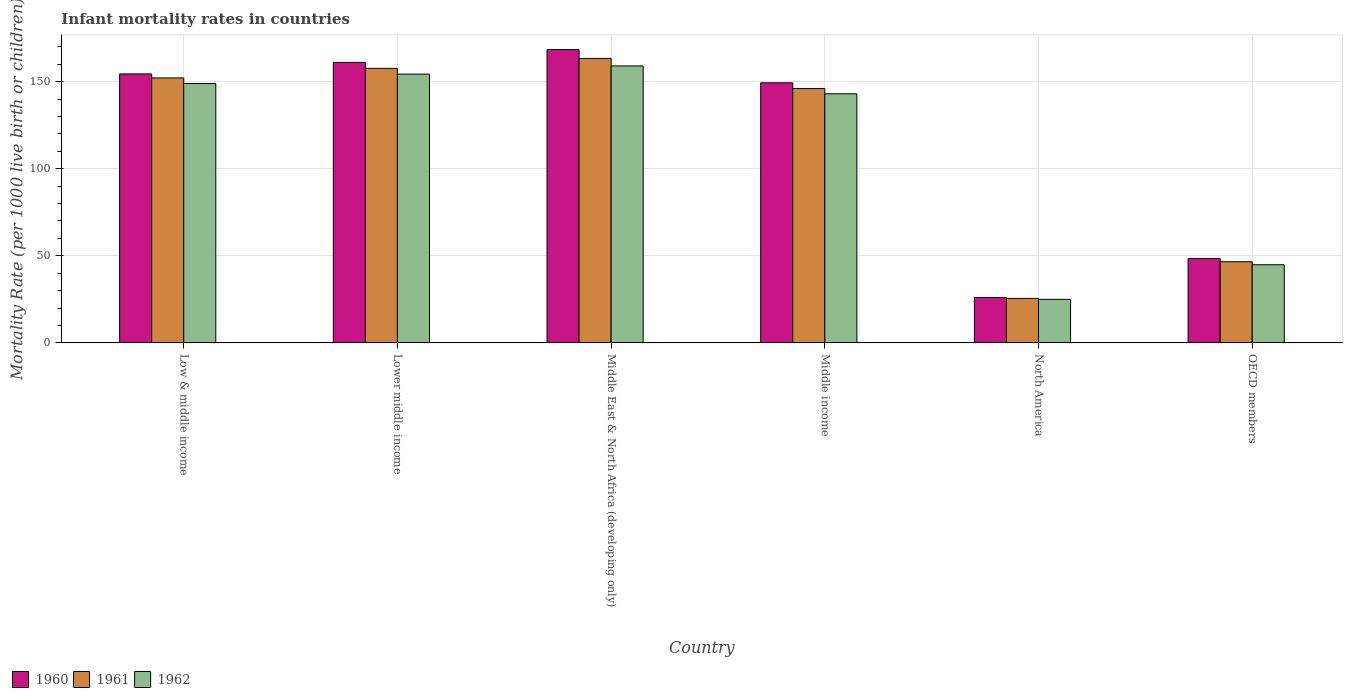How many groups of bars are there?
Your answer should be compact. 6. Are the number of bars per tick equal to the number of legend labels?
Make the answer very short. Yes. Are the number of bars on each tick of the X-axis equal?
Provide a short and direct response. Yes. How many bars are there on the 3rd tick from the left?
Offer a very short reply. 3. How many bars are there on the 1st tick from the right?
Your answer should be very brief. 3. What is the label of the 4th group of bars from the left?
Make the answer very short. Middle income. What is the infant mortality rate in 1962 in Low & middle income?
Your response must be concise. 148.9. Across all countries, what is the maximum infant mortality rate in 1960?
Keep it short and to the point. 168.4. Across all countries, what is the minimum infant mortality rate in 1962?
Your answer should be compact. 25.01. In which country was the infant mortality rate in 1960 maximum?
Offer a very short reply. Middle East & North Africa (developing only). In which country was the infant mortality rate in 1961 minimum?
Offer a terse response. North America. What is the total infant mortality rate in 1961 in the graph?
Offer a very short reply. 691.17. What is the difference between the infant mortality rate in 1962 in Low & middle income and that in OECD members?
Provide a short and direct response. 104.03. What is the difference between the infant mortality rate in 1961 in OECD members and the infant mortality rate in 1960 in North America?
Your answer should be very brief. 20.53. What is the average infant mortality rate in 1960 per country?
Provide a short and direct response. 117.95. What is the difference between the infant mortality rate of/in 1961 and infant mortality rate of/in 1962 in OECD members?
Keep it short and to the point. 1.74. In how many countries, is the infant mortality rate in 1960 greater than 10?
Give a very brief answer. 6. What is the ratio of the infant mortality rate in 1961 in Lower middle income to that in Middle income?
Give a very brief answer. 1.08. Is the infant mortality rate in 1960 in Lower middle income less than that in OECD members?
Your response must be concise. No. Is the difference between the infant mortality rate in 1961 in Middle East & North Africa (developing only) and North America greater than the difference between the infant mortality rate in 1962 in Middle East & North Africa (developing only) and North America?
Ensure brevity in your answer.  Yes. What is the difference between the highest and the second highest infant mortality rate in 1961?
Your response must be concise. -11.2. What is the difference between the highest and the lowest infant mortality rate in 1962?
Keep it short and to the point. 133.99. What does the 2nd bar from the right in Middle income represents?
Make the answer very short. 1961. What is the difference between two consecutive major ticks on the Y-axis?
Ensure brevity in your answer.  50. Are the values on the major ticks of Y-axis written in scientific E-notation?
Provide a succinct answer. No. Does the graph contain any zero values?
Provide a succinct answer. No. Does the graph contain grids?
Offer a terse response. Yes. How many legend labels are there?
Your answer should be compact. 3. What is the title of the graph?
Keep it short and to the point. Infant mortality rates in countries. What is the label or title of the X-axis?
Your response must be concise. Country. What is the label or title of the Y-axis?
Offer a very short reply. Mortality Rate (per 1000 live birth or children). What is the Mortality Rate (per 1000 live birth or children) in 1960 in Low & middle income?
Offer a terse response. 154.4. What is the Mortality Rate (per 1000 live birth or children) in 1961 in Low & middle income?
Offer a terse response. 152.1. What is the Mortality Rate (per 1000 live birth or children) in 1962 in Low & middle income?
Provide a short and direct response. 148.9. What is the Mortality Rate (per 1000 live birth or children) in 1960 in Lower middle income?
Offer a terse response. 161. What is the Mortality Rate (per 1000 live birth or children) of 1961 in Lower middle income?
Your response must be concise. 157.6. What is the Mortality Rate (per 1000 live birth or children) of 1962 in Lower middle income?
Provide a succinct answer. 154.3. What is the Mortality Rate (per 1000 live birth or children) of 1960 in Middle East & North Africa (developing only)?
Provide a short and direct response. 168.4. What is the Mortality Rate (per 1000 live birth or children) of 1961 in Middle East & North Africa (developing only)?
Provide a succinct answer. 163.3. What is the Mortality Rate (per 1000 live birth or children) of 1962 in Middle East & North Africa (developing only)?
Offer a terse response. 159. What is the Mortality Rate (per 1000 live birth or children) in 1960 in Middle income?
Provide a succinct answer. 149.3. What is the Mortality Rate (per 1000 live birth or children) in 1961 in Middle income?
Give a very brief answer. 146. What is the Mortality Rate (per 1000 live birth or children) in 1962 in Middle income?
Keep it short and to the point. 143. What is the Mortality Rate (per 1000 live birth or children) of 1960 in North America?
Provide a short and direct response. 26.08. What is the Mortality Rate (per 1000 live birth or children) of 1961 in North America?
Offer a very short reply. 25.56. What is the Mortality Rate (per 1000 live birth or children) of 1962 in North America?
Ensure brevity in your answer.  25.01. What is the Mortality Rate (per 1000 live birth or children) in 1960 in OECD members?
Offer a very short reply. 48.51. What is the Mortality Rate (per 1000 live birth or children) of 1961 in OECD members?
Ensure brevity in your answer.  46.61. What is the Mortality Rate (per 1000 live birth or children) of 1962 in OECD members?
Make the answer very short. 44.87. Across all countries, what is the maximum Mortality Rate (per 1000 live birth or children) of 1960?
Keep it short and to the point. 168.4. Across all countries, what is the maximum Mortality Rate (per 1000 live birth or children) of 1961?
Provide a short and direct response. 163.3. Across all countries, what is the maximum Mortality Rate (per 1000 live birth or children) in 1962?
Offer a terse response. 159. Across all countries, what is the minimum Mortality Rate (per 1000 live birth or children) of 1960?
Offer a very short reply. 26.08. Across all countries, what is the minimum Mortality Rate (per 1000 live birth or children) in 1961?
Ensure brevity in your answer.  25.56. Across all countries, what is the minimum Mortality Rate (per 1000 live birth or children) in 1962?
Your response must be concise. 25.01. What is the total Mortality Rate (per 1000 live birth or children) of 1960 in the graph?
Make the answer very short. 707.69. What is the total Mortality Rate (per 1000 live birth or children) in 1961 in the graph?
Give a very brief answer. 691.17. What is the total Mortality Rate (per 1000 live birth or children) in 1962 in the graph?
Ensure brevity in your answer.  675.08. What is the difference between the Mortality Rate (per 1000 live birth or children) of 1960 in Low & middle income and that in Lower middle income?
Provide a short and direct response. -6.6. What is the difference between the Mortality Rate (per 1000 live birth or children) of 1961 in Low & middle income and that in Lower middle income?
Give a very brief answer. -5.5. What is the difference between the Mortality Rate (per 1000 live birth or children) of 1962 in Low & middle income and that in Middle East & North Africa (developing only)?
Your answer should be very brief. -10.1. What is the difference between the Mortality Rate (per 1000 live birth or children) in 1960 in Low & middle income and that in Middle income?
Give a very brief answer. 5.1. What is the difference between the Mortality Rate (per 1000 live birth or children) of 1962 in Low & middle income and that in Middle income?
Keep it short and to the point. 5.9. What is the difference between the Mortality Rate (per 1000 live birth or children) of 1960 in Low & middle income and that in North America?
Provide a succinct answer. 128.32. What is the difference between the Mortality Rate (per 1000 live birth or children) of 1961 in Low & middle income and that in North America?
Offer a very short reply. 126.54. What is the difference between the Mortality Rate (per 1000 live birth or children) of 1962 in Low & middle income and that in North America?
Ensure brevity in your answer.  123.89. What is the difference between the Mortality Rate (per 1000 live birth or children) of 1960 in Low & middle income and that in OECD members?
Offer a terse response. 105.89. What is the difference between the Mortality Rate (per 1000 live birth or children) in 1961 in Low & middle income and that in OECD members?
Ensure brevity in your answer.  105.49. What is the difference between the Mortality Rate (per 1000 live birth or children) in 1962 in Low & middle income and that in OECD members?
Your answer should be compact. 104.03. What is the difference between the Mortality Rate (per 1000 live birth or children) in 1962 in Lower middle income and that in Middle East & North Africa (developing only)?
Make the answer very short. -4.7. What is the difference between the Mortality Rate (per 1000 live birth or children) of 1960 in Lower middle income and that in Middle income?
Ensure brevity in your answer.  11.7. What is the difference between the Mortality Rate (per 1000 live birth or children) in 1960 in Lower middle income and that in North America?
Offer a terse response. 134.92. What is the difference between the Mortality Rate (per 1000 live birth or children) of 1961 in Lower middle income and that in North America?
Make the answer very short. 132.04. What is the difference between the Mortality Rate (per 1000 live birth or children) in 1962 in Lower middle income and that in North America?
Keep it short and to the point. 129.29. What is the difference between the Mortality Rate (per 1000 live birth or children) in 1960 in Lower middle income and that in OECD members?
Your answer should be compact. 112.49. What is the difference between the Mortality Rate (per 1000 live birth or children) in 1961 in Lower middle income and that in OECD members?
Offer a terse response. 110.99. What is the difference between the Mortality Rate (per 1000 live birth or children) of 1962 in Lower middle income and that in OECD members?
Make the answer very short. 109.43. What is the difference between the Mortality Rate (per 1000 live birth or children) in 1962 in Middle East & North Africa (developing only) and that in Middle income?
Ensure brevity in your answer.  16. What is the difference between the Mortality Rate (per 1000 live birth or children) in 1960 in Middle East & North Africa (developing only) and that in North America?
Give a very brief answer. 142.32. What is the difference between the Mortality Rate (per 1000 live birth or children) of 1961 in Middle East & North Africa (developing only) and that in North America?
Give a very brief answer. 137.74. What is the difference between the Mortality Rate (per 1000 live birth or children) in 1962 in Middle East & North Africa (developing only) and that in North America?
Provide a short and direct response. 133.99. What is the difference between the Mortality Rate (per 1000 live birth or children) of 1960 in Middle East & North Africa (developing only) and that in OECD members?
Provide a succinct answer. 119.89. What is the difference between the Mortality Rate (per 1000 live birth or children) in 1961 in Middle East & North Africa (developing only) and that in OECD members?
Provide a short and direct response. 116.69. What is the difference between the Mortality Rate (per 1000 live birth or children) in 1962 in Middle East & North Africa (developing only) and that in OECD members?
Provide a short and direct response. 114.13. What is the difference between the Mortality Rate (per 1000 live birth or children) of 1960 in Middle income and that in North America?
Your answer should be compact. 123.22. What is the difference between the Mortality Rate (per 1000 live birth or children) of 1961 in Middle income and that in North America?
Ensure brevity in your answer.  120.44. What is the difference between the Mortality Rate (per 1000 live birth or children) of 1962 in Middle income and that in North America?
Make the answer very short. 117.99. What is the difference between the Mortality Rate (per 1000 live birth or children) in 1960 in Middle income and that in OECD members?
Ensure brevity in your answer.  100.79. What is the difference between the Mortality Rate (per 1000 live birth or children) in 1961 in Middle income and that in OECD members?
Offer a very short reply. 99.39. What is the difference between the Mortality Rate (per 1000 live birth or children) of 1962 in Middle income and that in OECD members?
Your answer should be compact. 98.13. What is the difference between the Mortality Rate (per 1000 live birth or children) of 1960 in North America and that in OECD members?
Your response must be concise. -22.42. What is the difference between the Mortality Rate (per 1000 live birth or children) of 1961 in North America and that in OECD members?
Your response must be concise. -21.06. What is the difference between the Mortality Rate (per 1000 live birth or children) of 1962 in North America and that in OECD members?
Provide a succinct answer. -19.86. What is the difference between the Mortality Rate (per 1000 live birth or children) of 1960 in Low & middle income and the Mortality Rate (per 1000 live birth or children) of 1962 in Lower middle income?
Offer a terse response. 0.1. What is the difference between the Mortality Rate (per 1000 live birth or children) of 1961 in Low & middle income and the Mortality Rate (per 1000 live birth or children) of 1962 in Lower middle income?
Your answer should be compact. -2.2. What is the difference between the Mortality Rate (per 1000 live birth or children) in 1960 in Low & middle income and the Mortality Rate (per 1000 live birth or children) in 1961 in Middle East & North Africa (developing only)?
Offer a terse response. -8.9. What is the difference between the Mortality Rate (per 1000 live birth or children) in 1960 in Low & middle income and the Mortality Rate (per 1000 live birth or children) in 1962 in Middle East & North Africa (developing only)?
Provide a succinct answer. -4.6. What is the difference between the Mortality Rate (per 1000 live birth or children) in 1961 in Low & middle income and the Mortality Rate (per 1000 live birth or children) in 1962 in Middle East & North Africa (developing only)?
Offer a terse response. -6.9. What is the difference between the Mortality Rate (per 1000 live birth or children) in 1960 in Low & middle income and the Mortality Rate (per 1000 live birth or children) in 1961 in Middle income?
Give a very brief answer. 8.4. What is the difference between the Mortality Rate (per 1000 live birth or children) in 1960 in Low & middle income and the Mortality Rate (per 1000 live birth or children) in 1961 in North America?
Your answer should be compact. 128.84. What is the difference between the Mortality Rate (per 1000 live birth or children) in 1960 in Low & middle income and the Mortality Rate (per 1000 live birth or children) in 1962 in North America?
Provide a short and direct response. 129.39. What is the difference between the Mortality Rate (per 1000 live birth or children) of 1961 in Low & middle income and the Mortality Rate (per 1000 live birth or children) of 1962 in North America?
Keep it short and to the point. 127.09. What is the difference between the Mortality Rate (per 1000 live birth or children) of 1960 in Low & middle income and the Mortality Rate (per 1000 live birth or children) of 1961 in OECD members?
Make the answer very short. 107.79. What is the difference between the Mortality Rate (per 1000 live birth or children) of 1960 in Low & middle income and the Mortality Rate (per 1000 live birth or children) of 1962 in OECD members?
Provide a short and direct response. 109.53. What is the difference between the Mortality Rate (per 1000 live birth or children) in 1961 in Low & middle income and the Mortality Rate (per 1000 live birth or children) in 1962 in OECD members?
Your response must be concise. 107.23. What is the difference between the Mortality Rate (per 1000 live birth or children) in 1960 in Lower middle income and the Mortality Rate (per 1000 live birth or children) in 1962 in Middle East & North Africa (developing only)?
Provide a short and direct response. 2. What is the difference between the Mortality Rate (per 1000 live birth or children) in 1960 in Lower middle income and the Mortality Rate (per 1000 live birth or children) in 1961 in Middle income?
Offer a terse response. 15. What is the difference between the Mortality Rate (per 1000 live birth or children) of 1960 in Lower middle income and the Mortality Rate (per 1000 live birth or children) of 1962 in Middle income?
Offer a terse response. 18. What is the difference between the Mortality Rate (per 1000 live birth or children) of 1960 in Lower middle income and the Mortality Rate (per 1000 live birth or children) of 1961 in North America?
Your response must be concise. 135.44. What is the difference between the Mortality Rate (per 1000 live birth or children) of 1960 in Lower middle income and the Mortality Rate (per 1000 live birth or children) of 1962 in North America?
Offer a very short reply. 135.99. What is the difference between the Mortality Rate (per 1000 live birth or children) in 1961 in Lower middle income and the Mortality Rate (per 1000 live birth or children) in 1962 in North America?
Your answer should be compact. 132.59. What is the difference between the Mortality Rate (per 1000 live birth or children) in 1960 in Lower middle income and the Mortality Rate (per 1000 live birth or children) in 1961 in OECD members?
Your answer should be very brief. 114.39. What is the difference between the Mortality Rate (per 1000 live birth or children) of 1960 in Lower middle income and the Mortality Rate (per 1000 live birth or children) of 1962 in OECD members?
Your answer should be compact. 116.13. What is the difference between the Mortality Rate (per 1000 live birth or children) of 1961 in Lower middle income and the Mortality Rate (per 1000 live birth or children) of 1962 in OECD members?
Provide a short and direct response. 112.73. What is the difference between the Mortality Rate (per 1000 live birth or children) in 1960 in Middle East & North Africa (developing only) and the Mortality Rate (per 1000 live birth or children) in 1961 in Middle income?
Make the answer very short. 22.4. What is the difference between the Mortality Rate (per 1000 live birth or children) of 1960 in Middle East & North Africa (developing only) and the Mortality Rate (per 1000 live birth or children) of 1962 in Middle income?
Provide a succinct answer. 25.4. What is the difference between the Mortality Rate (per 1000 live birth or children) of 1961 in Middle East & North Africa (developing only) and the Mortality Rate (per 1000 live birth or children) of 1962 in Middle income?
Provide a short and direct response. 20.3. What is the difference between the Mortality Rate (per 1000 live birth or children) in 1960 in Middle East & North Africa (developing only) and the Mortality Rate (per 1000 live birth or children) in 1961 in North America?
Keep it short and to the point. 142.84. What is the difference between the Mortality Rate (per 1000 live birth or children) in 1960 in Middle East & North Africa (developing only) and the Mortality Rate (per 1000 live birth or children) in 1962 in North America?
Make the answer very short. 143.39. What is the difference between the Mortality Rate (per 1000 live birth or children) of 1961 in Middle East & North Africa (developing only) and the Mortality Rate (per 1000 live birth or children) of 1962 in North America?
Ensure brevity in your answer.  138.29. What is the difference between the Mortality Rate (per 1000 live birth or children) in 1960 in Middle East & North Africa (developing only) and the Mortality Rate (per 1000 live birth or children) in 1961 in OECD members?
Your answer should be very brief. 121.79. What is the difference between the Mortality Rate (per 1000 live birth or children) in 1960 in Middle East & North Africa (developing only) and the Mortality Rate (per 1000 live birth or children) in 1962 in OECD members?
Keep it short and to the point. 123.53. What is the difference between the Mortality Rate (per 1000 live birth or children) of 1961 in Middle East & North Africa (developing only) and the Mortality Rate (per 1000 live birth or children) of 1962 in OECD members?
Your answer should be compact. 118.43. What is the difference between the Mortality Rate (per 1000 live birth or children) of 1960 in Middle income and the Mortality Rate (per 1000 live birth or children) of 1961 in North America?
Provide a succinct answer. 123.74. What is the difference between the Mortality Rate (per 1000 live birth or children) of 1960 in Middle income and the Mortality Rate (per 1000 live birth or children) of 1962 in North America?
Give a very brief answer. 124.29. What is the difference between the Mortality Rate (per 1000 live birth or children) in 1961 in Middle income and the Mortality Rate (per 1000 live birth or children) in 1962 in North America?
Provide a short and direct response. 120.99. What is the difference between the Mortality Rate (per 1000 live birth or children) in 1960 in Middle income and the Mortality Rate (per 1000 live birth or children) in 1961 in OECD members?
Provide a succinct answer. 102.69. What is the difference between the Mortality Rate (per 1000 live birth or children) of 1960 in Middle income and the Mortality Rate (per 1000 live birth or children) of 1962 in OECD members?
Provide a short and direct response. 104.43. What is the difference between the Mortality Rate (per 1000 live birth or children) of 1961 in Middle income and the Mortality Rate (per 1000 live birth or children) of 1962 in OECD members?
Your response must be concise. 101.13. What is the difference between the Mortality Rate (per 1000 live birth or children) in 1960 in North America and the Mortality Rate (per 1000 live birth or children) in 1961 in OECD members?
Your answer should be compact. -20.53. What is the difference between the Mortality Rate (per 1000 live birth or children) in 1960 in North America and the Mortality Rate (per 1000 live birth or children) in 1962 in OECD members?
Ensure brevity in your answer.  -18.79. What is the difference between the Mortality Rate (per 1000 live birth or children) of 1961 in North America and the Mortality Rate (per 1000 live birth or children) of 1962 in OECD members?
Your response must be concise. -19.32. What is the average Mortality Rate (per 1000 live birth or children) of 1960 per country?
Your answer should be compact. 117.95. What is the average Mortality Rate (per 1000 live birth or children) in 1961 per country?
Give a very brief answer. 115.19. What is the average Mortality Rate (per 1000 live birth or children) in 1962 per country?
Keep it short and to the point. 112.51. What is the difference between the Mortality Rate (per 1000 live birth or children) in 1960 and Mortality Rate (per 1000 live birth or children) in 1961 in Low & middle income?
Provide a short and direct response. 2.3. What is the difference between the Mortality Rate (per 1000 live birth or children) of 1960 and Mortality Rate (per 1000 live birth or children) of 1962 in Low & middle income?
Your answer should be compact. 5.5. What is the difference between the Mortality Rate (per 1000 live birth or children) of 1960 and Mortality Rate (per 1000 live birth or children) of 1961 in Lower middle income?
Give a very brief answer. 3.4. What is the difference between the Mortality Rate (per 1000 live birth or children) of 1961 and Mortality Rate (per 1000 live birth or children) of 1962 in Lower middle income?
Your answer should be very brief. 3.3. What is the difference between the Mortality Rate (per 1000 live birth or children) in 1960 and Mortality Rate (per 1000 live birth or children) in 1961 in North America?
Provide a succinct answer. 0.53. What is the difference between the Mortality Rate (per 1000 live birth or children) of 1960 and Mortality Rate (per 1000 live birth or children) of 1962 in North America?
Ensure brevity in your answer.  1.08. What is the difference between the Mortality Rate (per 1000 live birth or children) of 1961 and Mortality Rate (per 1000 live birth or children) of 1962 in North America?
Your response must be concise. 0.55. What is the difference between the Mortality Rate (per 1000 live birth or children) in 1960 and Mortality Rate (per 1000 live birth or children) in 1961 in OECD members?
Your response must be concise. 1.89. What is the difference between the Mortality Rate (per 1000 live birth or children) of 1960 and Mortality Rate (per 1000 live birth or children) of 1962 in OECD members?
Offer a terse response. 3.64. What is the difference between the Mortality Rate (per 1000 live birth or children) of 1961 and Mortality Rate (per 1000 live birth or children) of 1962 in OECD members?
Provide a succinct answer. 1.74. What is the ratio of the Mortality Rate (per 1000 live birth or children) in 1960 in Low & middle income to that in Lower middle income?
Give a very brief answer. 0.96. What is the ratio of the Mortality Rate (per 1000 live birth or children) in 1961 in Low & middle income to that in Lower middle income?
Your answer should be compact. 0.97. What is the ratio of the Mortality Rate (per 1000 live birth or children) of 1962 in Low & middle income to that in Lower middle income?
Give a very brief answer. 0.96. What is the ratio of the Mortality Rate (per 1000 live birth or children) of 1960 in Low & middle income to that in Middle East & North Africa (developing only)?
Keep it short and to the point. 0.92. What is the ratio of the Mortality Rate (per 1000 live birth or children) in 1961 in Low & middle income to that in Middle East & North Africa (developing only)?
Make the answer very short. 0.93. What is the ratio of the Mortality Rate (per 1000 live birth or children) in 1962 in Low & middle income to that in Middle East & North Africa (developing only)?
Ensure brevity in your answer.  0.94. What is the ratio of the Mortality Rate (per 1000 live birth or children) in 1960 in Low & middle income to that in Middle income?
Offer a very short reply. 1.03. What is the ratio of the Mortality Rate (per 1000 live birth or children) of 1961 in Low & middle income to that in Middle income?
Offer a terse response. 1.04. What is the ratio of the Mortality Rate (per 1000 live birth or children) of 1962 in Low & middle income to that in Middle income?
Provide a succinct answer. 1.04. What is the ratio of the Mortality Rate (per 1000 live birth or children) in 1960 in Low & middle income to that in North America?
Your answer should be very brief. 5.92. What is the ratio of the Mortality Rate (per 1000 live birth or children) of 1961 in Low & middle income to that in North America?
Provide a short and direct response. 5.95. What is the ratio of the Mortality Rate (per 1000 live birth or children) in 1962 in Low & middle income to that in North America?
Make the answer very short. 5.95. What is the ratio of the Mortality Rate (per 1000 live birth or children) in 1960 in Low & middle income to that in OECD members?
Offer a terse response. 3.18. What is the ratio of the Mortality Rate (per 1000 live birth or children) of 1961 in Low & middle income to that in OECD members?
Your response must be concise. 3.26. What is the ratio of the Mortality Rate (per 1000 live birth or children) of 1962 in Low & middle income to that in OECD members?
Give a very brief answer. 3.32. What is the ratio of the Mortality Rate (per 1000 live birth or children) in 1960 in Lower middle income to that in Middle East & North Africa (developing only)?
Offer a terse response. 0.96. What is the ratio of the Mortality Rate (per 1000 live birth or children) in 1961 in Lower middle income to that in Middle East & North Africa (developing only)?
Your answer should be compact. 0.97. What is the ratio of the Mortality Rate (per 1000 live birth or children) in 1962 in Lower middle income to that in Middle East & North Africa (developing only)?
Offer a terse response. 0.97. What is the ratio of the Mortality Rate (per 1000 live birth or children) of 1960 in Lower middle income to that in Middle income?
Ensure brevity in your answer.  1.08. What is the ratio of the Mortality Rate (per 1000 live birth or children) of 1961 in Lower middle income to that in Middle income?
Give a very brief answer. 1.08. What is the ratio of the Mortality Rate (per 1000 live birth or children) in 1962 in Lower middle income to that in Middle income?
Make the answer very short. 1.08. What is the ratio of the Mortality Rate (per 1000 live birth or children) of 1960 in Lower middle income to that in North America?
Provide a short and direct response. 6.17. What is the ratio of the Mortality Rate (per 1000 live birth or children) in 1961 in Lower middle income to that in North America?
Your answer should be compact. 6.17. What is the ratio of the Mortality Rate (per 1000 live birth or children) of 1962 in Lower middle income to that in North America?
Provide a short and direct response. 6.17. What is the ratio of the Mortality Rate (per 1000 live birth or children) of 1960 in Lower middle income to that in OECD members?
Give a very brief answer. 3.32. What is the ratio of the Mortality Rate (per 1000 live birth or children) of 1961 in Lower middle income to that in OECD members?
Your answer should be compact. 3.38. What is the ratio of the Mortality Rate (per 1000 live birth or children) in 1962 in Lower middle income to that in OECD members?
Offer a terse response. 3.44. What is the ratio of the Mortality Rate (per 1000 live birth or children) in 1960 in Middle East & North Africa (developing only) to that in Middle income?
Ensure brevity in your answer.  1.13. What is the ratio of the Mortality Rate (per 1000 live birth or children) in 1961 in Middle East & North Africa (developing only) to that in Middle income?
Provide a short and direct response. 1.12. What is the ratio of the Mortality Rate (per 1000 live birth or children) in 1962 in Middle East & North Africa (developing only) to that in Middle income?
Make the answer very short. 1.11. What is the ratio of the Mortality Rate (per 1000 live birth or children) in 1960 in Middle East & North Africa (developing only) to that in North America?
Your response must be concise. 6.46. What is the ratio of the Mortality Rate (per 1000 live birth or children) of 1961 in Middle East & North Africa (developing only) to that in North America?
Give a very brief answer. 6.39. What is the ratio of the Mortality Rate (per 1000 live birth or children) in 1962 in Middle East & North Africa (developing only) to that in North America?
Your response must be concise. 6.36. What is the ratio of the Mortality Rate (per 1000 live birth or children) of 1960 in Middle East & North Africa (developing only) to that in OECD members?
Your answer should be very brief. 3.47. What is the ratio of the Mortality Rate (per 1000 live birth or children) of 1961 in Middle East & North Africa (developing only) to that in OECD members?
Make the answer very short. 3.5. What is the ratio of the Mortality Rate (per 1000 live birth or children) in 1962 in Middle East & North Africa (developing only) to that in OECD members?
Make the answer very short. 3.54. What is the ratio of the Mortality Rate (per 1000 live birth or children) of 1960 in Middle income to that in North America?
Your answer should be compact. 5.72. What is the ratio of the Mortality Rate (per 1000 live birth or children) of 1961 in Middle income to that in North America?
Offer a terse response. 5.71. What is the ratio of the Mortality Rate (per 1000 live birth or children) of 1962 in Middle income to that in North America?
Offer a very short reply. 5.72. What is the ratio of the Mortality Rate (per 1000 live birth or children) in 1960 in Middle income to that in OECD members?
Ensure brevity in your answer.  3.08. What is the ratio of the Mortality Rate (per 1000 live birth or children) of 1961 in Middle income to that in OECD members?
Give a very brief answer. 3.13. What is the ratio of the Mortality Rate (per 1000 live birth or children) in 1962 in Middle income to that in OECD members?
Ensure brevity in your answer.  3.19. What is the ratio of the Mortality Rate (per 1000 live birth or children) in 1960 in North America to that in OECD members?
Offer a very short reply. 0.54. What is the ratio of the Mortality Rate (per 1000 live birth or children) of 1961 in North America to that in OECD members?
Your answer should be compact. 0.55. What is the ratio of the Mortality Rate (per 1000 live birth or children) in 1962 in North America to that in OECD members?
Provide a short and direct response. 0.56. What is the difference between the highest and the lowest Mortality Rate (per 1000 live birth or children) in 1960?
Provide a short and direct response. 142.32. What is the difference between the highest and the lowest Mortality Rate (per 1000 live birth or children) of 1961?
Keep it short and to the point. 137.74. What is the difference between the highest and the lowest Mortality Rate (per 1000 live birth or children) in 1962?
Make the answer very short. 133.99. 